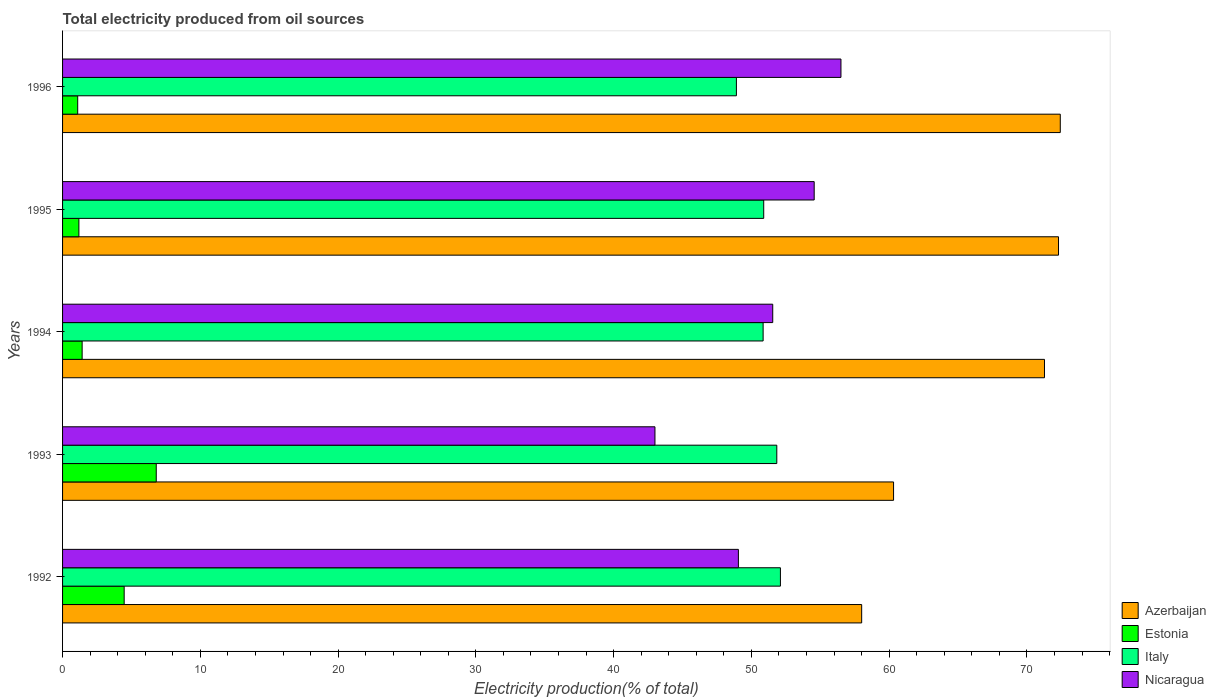How many different coloured bars are there?
Offer a terse response. 4. How many groups of bars are there?
Your answer should be very brief. 5. Are the number of bars per tick equal to the number of legend labels?
Make the answer very short. Yes. Are the number of bars on each tick of the Y-axis equal?
Provide a short and direct response. Yes. What is the label of the 3rd group of bars from the top?
Provide a succinct answer. 1994. In how many cases, is the number of bars for a given year not equal to the number of legend labels?
Offer a terse response. 0. What is the total electricity produced in Italy in 1993?
Keep it short and to the point. 51.84. Across all years, what is the maximum total electricity produced in Nicaragua?
Give a very brief answer. 56.5. Across all years, what is the minimum total electricity produced in Nicaragua?
Provide a succinct answer. 43. In which year was the total electricity produced in Estonia minimum?
Provide a succinct answer. 1996. What is the total total electricity produced in Nicaragua in the graph?
Ensure brevity in your answer.  254.65. What is the difference between the total electricity produced in Azerbaijan in 1993 and that in 1995?
Make the answer very short. -11.97. What is the difference between the total electricity produced in Estonia in 1994 and the total electricity produced in Italy in 1995?
Make the answer very short. -49.47. What is the average total electricity produced in Azerbaijan per year?
Offer a terse response. 66.86. In the year 1993, what is the difference between the total electricity produced in Azerbaijan and total electricity produced in Estonia?
Offer a very short reply. 53.52. What is the ratio of the total electricity produced in Italy in 1992 to that in 1993?
Ensure brevity in your answer.  1.01. Is the total electricity produced in Italy in 1992 less than that in 1993?
Provide a short and direct response. No. Is the difference between the total electricity produced in Azerbaijan in 1993 and 1996 greater than the difference between the total electricity produced in Estonia in 1993 and 1996?
Your answer should be compact. No. What is the difference between the highest and the second highest total electricity produced in Nicaragua?
Your answer should be very brief. 1.94. What is the difference between the highest and the lowest total electricity produced in Estonia?
Your answer should be compact. 5.7. In how many years, is the total electricity produced in Estonia greater than the average total electricity produced in Estonia taken over all years?
Your response must be concise. 2. Is it the case that in every year, the sum of the total electricity produced in Azerbaijan and total electricity produced in Italy is greater than the sum of total electricity produced in Nicaragua and total electricity produced in Estonia?
Your answer should be compact. Yes. What does the 1st bar from the top in 1994 represents?
Offer a very short reply. Nicaragua. What does the 3rd bar from the bottom in 1996 represents?
Provide a short and direct response. Italy. Is it the case that in every year, the sum of the total electricity produced in Azerbaijan and total electricity produced in Italy is greater than the total electricity produced in Estonia?
Ensure brevity in your answer.  Yes. How many bars are there?
Offer a terse response. 20. Are all the bars in the graph horizontal?
Provide a short and direct response. Yes. How many legend labels are there?
Give a very brief answer. 4. How are the legend labels stacked?
Offer a very short reply. Vertical. What is the title of the graph?
Ensure brevity in your answer.  Total electricity produced from oil sources. Does "Barbados" appear as one of the legend labels in the graph?
Your answer should be compact. No. What is the label or title of the X-axis?
Keep it short and to the point. Electricity production(% of total). What is the label or title of the Y-axis?
Your response must be concise. Years. What is the Electricity production(% of total) of Azerbaijan in 1992?
Give a very brief answer. 58. What is the Electricity production(% of total) in Estonia in 1992?
Your answer should be very brief. 4.47. What is the Electricity production(% of total) of Italy in 1992?
Your answer should be compact. 52.1. What is the Electricity production(% of total) in Nicaragua in 1992?
Your answer should be very brief. 49.05. What is the Electricity production(% of total) of Azerbaijan in 1993?
Make the answer very short. 60.32. What is the Electricity production(% of total) in Estonia in 1993?
Keep it short and to the point. 6.8. What is the Electricity production(% of total) of Italy in 1993?
Give a very brief answer. 51.84. What is the Electricity production(% of total) of Nicaragua in 1993?
Offer a very short reply. 43. What is the Electricity production(% of total) of Azerbaijan in 1994?
Offer a terse response. 71.27. What is the Electricity production(% of total) in Estonia in 1994?
Make the answer very short. 1.42. What is the Electricity production(% of total) in Italy in 1994?
Offer a terse response. 50.85. What is the Electricity production(% of total) of Nicaragua in 1994?
Make the answer very short. 51.55. What is the Electricity production(% of total) of Azerbaijan in 1995?
Your answer should be compact. 72.29. What is the Electricity production(% of total) of Estonia in 1995?
Ensure brevity in your answer.  1.18. What is the Electricity production(% of total) in Italy in 1995?
Your answer should be compact. 50.89. What is the Electricity production(% of total) of Nicaragua in 1995?
Make the answer very short. 54.56. What is the Electricity production(% of total) of Azerbaijan in 1996?
Give a very brief answer. 72.42. What is the Electricity production(% of total) in Estonia in 1996?
Make the answer very short. 1.1. What is the Electricity production(% of total) of Italy in 1996?
Make the answer very short. 48.91. What is the Electricity production(% of total) in Nicaragua in 1996?
Provide a short and direct response. 56.5. Across all years, what is the maximum Electricity production(% of total) in Azerbaijan?
Offer a terse response. 72.42. Across all years, what is the maximum Electricity production(% of total) of Estonia?
Give a very brief answer. 6.8. Across all years, what is the maximum Electricity production(% of total) in Italy?
Make the answer very short. 52.1. Across all years, what is the maximum Electricity production(% of total) of Nicaragua?
Ensure brevity in your answer.  56.5. Across all years, what is the minimum Electricity production(% of total) in Azerbaijan?
Offer a terse response. 58. Across all years, what is the minimum Electricity production(% of total) of Estonia?
Your answer should be very brief. 1.1. Across all years, what is the minimum Electricity production(% of total) in Italy?
Offer a terse response. 48.91. Across all years, what is the minimum Electricity production(% of total) of Nicaragua?
Your answer should be compact. 43. What is the total Electricity production(% of total) in Azerbaijan in the graph?
Your answer should be very brief. 334.3. What is the total Electricity production(% of total) in Estonia in the graph?
Ensure brevity in your answer.  14.98. What is the total Electricity production(% of total) in Italy in the graph?
Offer a terse response. 254.6. What is the total Electricity production(% of total) of Nicaragua in the graph?
Provide a short and direct response. 254.65. What is the difference between the Electricity production(% of total) of Azerbaijan in 1992 and that in 1993?
Your answer should be very brief. -2.31. What is the difference between the Electricity production(% of total) of Estonia in 1992 and that in 1993?
Your response must be concise. -2.33. What is the difference between the Electricity production(% of total) of Italy in 1992 and that in 1993?
Your answer should be compact. 0.26. What is the difference between the Electricity production(% of total) in Nicaragua in 1992 and that in 1993?
Your answer should be compact. 6.06. What is the difference between the Electricity production(% of total) of Azerbaijan in 1992 and that in 1994?
Give a very brief answer. -13.27. What is the difference between the Electricity production(% of total) of Estonia in 1992 and that in 1994?
Your answer should be compact. 3.05. What is the difference between the Electricity production(% of total) of Italy in 1992 and that in 1994?
Your answer should be very brief. 1.26. What is the difference between the Electricity production(% of total) of Nicaragua in 1992 and that in 1994?
Your answer should be very brief. -2.49. What is the difference between the Electricity production(% of total) of Azerbaijan in 1992 and that in 1995?
Give a very brief answer. -14.29. What is the difference between the Electricity production(% of total) in Estonia in 1992 and that in 1995?
Ensure brevity in your answer.  3.29. What is the difference between the Electricity production(% of total) in Italy in 1992 and that in 1995?
Make the answer very short. 1.21. What is the difference between the Electricity production(% of total) in Nicaragua in 1992 and that in 1995?
Your answer should be compact. -5.5. What is the difference between the Electricity production(% of total) in Azerbaijan in 1992 and that in 1996?
Offer a very short reply. -14.42. What is the difference between the Electricity production(% of total) in Estonia in 1992 and that in 1996?
Ensure brevity in your answer.  3.37. What is the difference between the Electricity production(% of total) of Italy in 1992 and that in 1996?
Your answer should be very brief. 3.2. What is the difference between the Electricity production(% of total) in Nicaragua in 1992 and that in 1996?
Your answer should be compact. -7.44. What is the difference between the Electricity production(% of total) of Azerbaijan in 1993 and that in 1994?
Your answer should be compact. -10.95. What is the difference between the Electricity production(% of total) of Estonia in 1993 and that in 1994?
Offer a very short reply. 5.38. What is the difference between the Electricity production(% of total) of Nicaragua in 1993 and that in 1994?
Keep it short and to the point. -8.55. What is the difference between the Electricity production(% of total) in Azerbaijan in 1993 and that in 1995?
Your response must be concise. -11.97. What is the difference between the Electricity production(% of total) in Estonia in 1993 and that in 1995?
Offer a very short reply. 5.62. What is the difference between the Electricity production(% of total) in Italy in 1993 and that in 1995?
Offer a terse response. 0.95. What is the difference between the Electricity production(% of total) in Nicaragua in 1993 and that in 1995?
Your answer should be compact. -11.56. What is the difference between the Electricity production(% of total) of Azerbaijan in 1993 and that in 1996?
Offer a very short reply. -12.1. What is the difference between the Electricity production(% of total) of Estonia in 1993 and that in 1996?
Make the answer very short. 5.7. What is the difference between the Electricity production(% of total) of Italy in 1993 and that in 1996?
Provide a short and direct response. 2.93. What is the difference between the Electricity production(% of total) of Nicaragua in 1993 and that in 1996?
Offer a terse response. -13.5. What is the difference between the Electricity production(% of total) of Azerbaijan in 1994 and that in 1995?
Your response must be concise. -1.02. What is the difference between the Electricity production(% of total) of Estonia in 1994 and that in 1995?
Offer a very short reply. 0.24. What is the difference between the Electricity production(% of total) in Italy in 1994 and that in 1995?
Offer a very short reply. -0.04. What is the difference between the Electricity production(% of total) of Nicaragua in 1994 and that in 1995?
Keep it short and to the point. -3.01. What is the difference between the Electricity production(% of total) of Azerbaijan in 1994 and that in 1996?
Your answer should be very brief. -1.15. What is the difference between the Electricity production(% of total) in Estonia in 1994 and that in 1996?
Your answer should be very brief. 0.32. What is the difference between the Electricity production(% of total) of Italy in 1994 and that in 1996?
Your answer should be compact. 1.94. What is the difference between the Electricity production(% of total) of Nicaragua in 1994 and that in 1996?
Make the answer very short. -4.95. What is the difference between the Electricity production(% of total) in Azerbaijan in 1995 and that in 1996?
Provide a short and direct response. -0.13. What is the difference between the Electricity production(% of total) in Estonia in 1995 and that in 1996?
Keep it short and to the point. 0.09. What is the difference between the Electricity production(% of total) in Italy in 1995 and that in 1996?
Offer a terse response. 1.98. What is the difference between the Electricity production(% of total) in Nicaragua in 1995 and that in 1996?
Your answer should be very brief. -1.94. What is the difference between the Electricity production(% of total) of Azerbaijan in 1992 and the Electricity production(% of total) of Estonia in 1993?
Keep it short and to the point. 51.2. What is the difference between the Electricity production(% of total) in Azerbaijan in 1992 and the Electricity production(% of total) in Italy in 1993?
Offer a very short reply. 6.16. What is the difference between the Electricity production(% of total) in Azerbaijan in 1992 and the Electricity production(% of total) in Nicaragua in 1993?
Your answer should be compact. 15.01. What is the difference between the Electricity production(% of total) of Estonia in 1992 and the Electricity production(% of total) of Italy in 1993?
Your answer should be very brief. -47.37. What is the difference between the Electricity production(% of total) in Estonia in 1992 and the Electricity production(% of total) in Nicaragua in 1993?
Provide a succinct answer. -38.53. What is the difference between the Electricity production(% of total) in Italy in 1992 and the Electricity production(% of total) in Nicaragua in 1993?
Provide a succinct answer. 9.11. What is the difference between the Electricity production(% of total) in Azerbaijan in 1992 and the Electricity production(% of total) in Estonia in 1994?
Make the answer very short. 56.58. What is the difference between the Electricity production(% of total) of Azerbaijan in 1992 and the Electricity production(% of total) of Italy in 1994?
Offer a very short reply. 7.15. What is the difference between the Electricity production(% of total) of Azerbaijan in 1992 and the Electricity production(% of total) of Nicaragua in 1994?
Keep it short and to the point. 6.46. What is the difference between the Electricity production(% of total) in Estonia in 1992 and the Electricity production(% of total) in Italy in 1994?
Your answer should be very brief. -46.38. What is the difference between the Electricity production(% of total) in Estonia in 1992 and the Electricity production(% of total) in Nicaragua in 1994?
Provide a succinct answer. -47.08. What is the difference between the Electricity production(% of total) of Italy in 1992 and the Electricity production(% of total) of Nicaragua in 1994?
Provide a succinct answer. 0.56. What is the difference between the Electricity production(% of total) of Azerbaijan in 1992 and the Electricity production(% of total) of Estonia in 1995?
Provide a succinct answer. 56.82. What is the difference between the Electricity production(% of total) in Azerbaijan in 1992 and the Electricity production(% of total) in Italy in 1995?
Keep it short and to the point. 7.11. What is the difference between the Electricity production(% of total) in Azerbaijan in 1992 and the Electricity production(% of total) in Nicaragua in 1995?
Ensure brevity in your answer.  3.45. What is the difference between the Electricity production(% of total) of Estonia in 1992 and the Electricity production(% of total) of Italy in 1995?
Keep it short and to the point. -46.42. What is the difference between the Electricity production(% of total) of Estonia in 1992 and the Electricity production(% of total) of Nicaragua in 1995?
Offer a terse response. -50.08. What is the difference between the Electricity production(% of total) in Italy in 1992 and the Electricity production(% of total) in Nicaragua in 1995?
Your answer should be very brief. -2.45. What is the difference between the Electricity production(% of total) of Azerbaijan in 1992 and the Electricity production(% of total) of Estonia in 1996?
Make the answer very short. 56.9. What is the difference between the Electricity production(% of total) in Azerbaijan in 1992 and the Electricity production(% of total) in Italy in 1996?
Provide a short and direct response. 9.09. What is the difference between the Electricity production(% of total) in Azerbaijan in 1992 and the Electricity production(% of total) in Nicaragua in 1996?
Provide a short and direct response. 1.5. What is the difference between the Electricity production(% of total) in Estonia in 1992 and the Electricity production(% of total) in Italy in 1996?
Give a very brief answer. -44.44. What is the difference between the Electricity production(% of total) of Estonia in 1992 and the Electricity production(% of total) of Nicaragua in 1996?
Provide a succinct answer. -52.03. What is the difference between the Electricity production(% of total) in Italy in 1992 and the Electricity production(% of total) in Nicaragua in 1996?
Your answer should be very brief. -4.39. What is the difference between the Electricity production(% of total) of Azerbaijan in 1993 and the Electricity production(% of total) of Estonia in 1994?
Your answer should be very brief. 58.9. What is the difference between the Electricity production(% of total) of Azerbaijan in 1993 and the Electricity production(% of total) of Italy in 1994?
Give a very brief answer. 9.47. What is the difference between the Electricity production(% of total) of Azerbaijan in 1993 and the Electricity production(% of total) of Nicaragua in 1994?
Keep it short and to the point. 8.77. What is the difference between the Electricity production(% of total) of Estonia in 1993 and the Electricity production(% of total) of Italy in 1994?
Provide a short and direct response. -44.05. What is the difference between the Electricity production(% of total) in Estonia in 1993 and the Electricity production(% of total) in Nicaragua in 1994?
Provide a short and direct response. -44.75. What is the difference between the Electricity production(% of total) of Italy in 1993 and the Electricity production(% of total) of Nicaragua in 1994?
Your answer should be very brief. 0.3. What is the difference between the Electricity production(% of total) in Azerbaijan in 1993 and the Electricity production(% of total) in Estonia in 1995?
Offer a terse response. 59.13. What is the difference between the Electricity production(% of total) in Azerbaijan in 1993 and the Electricity production(% of total) in Italy in 1995?
Provide a short and direct response. 9.42. What is the difference between the Electricity production(% of total) of Azerbaijan in 1993 and the Electricity production(% of total) of Nicaragua in 1995?
Your answer should be compact. 5.76. What is the difference between the Electricity production(% of total) of Estonia in 1993 and the Electricity production(% of total) of Italy in 1995?
Offer a terse response. -44.09. What is the difference between the Electricity production(% of total) in Estonia in 1993 and the Electricity production(% of total) in Nicaragua in 1995?
Offer a terse response. -47.75. What is the difference between the Electricity production(% of total) in Italy in 1993 and the Electricity production(% of total) in Nicaragua in 1995?
Your response must be concise. -2.71. What is the difference between the Electricity production(% of total) in Azerbaijan in 1993 and the Electricity production(% of total) in Estonia in 1996?
Your response must be concise. 59.22. What is the difference between the Electricity production(% of total) in Azerbaijan in 1993 and the Electricity production(% of total) in Italy in 1996?
Your response must be concise. 11.41. What is the difference between the Electricity production(% of total) in Azerbaijan in 1993 and the Electricity production(% of total) in Nicaragua in 1996?
Provide a succinct answer. 3.82. What is the difference between the Electricity production(% of total) of Estonia in 1993 and the Electricity production(% of total) of Italy in 1996?
Your answer should be very brief. -42.11. What is the difference between the Electricity production(% of total) of Estonia in 1993 and the Electricity production(% of total) of Nicaragua in 1996?
Offer a very short reply. -49.7. What is the difference between the Electricity production(% of total) of Italy in 1993 and the Electricity production(% of total) of Nicaragua in 1996?
Your answer should be compact. -4.66. What is the difference between the Electricity production(% of total) in Azerbaijan in 1994 and the Electricity production(% of total) in Estonia in 1995?
Your response must be concise. 70.09. What is the difference between the Electricity production(% of total) of Azerbaijan in 1994 and the Electricity production(% of total) of Italy in 1995?
Provide a short and direct response. 20.38. What is the difference between the Electricity production(% of total) in Azerbaijan in 1994 and the Electricity production(% of total) in Nicaragua in 1995?
Your answer should be very brief. 16.72. What is the difference between the Electricity production(% of total) in Estonia in 1994 and the Electricity production(% of total) in Italy in 1995?
Make the answer very short. -49.47. What is the difference between the Electricity production(% of total) in Estonia in 1994 and the Electricity production(% of total) in Nicaragua in 1995?
Ensure brevity in your answer.  -53.13. What is the difference between the Electricity production(% of total) in Italy in 1994 and the Electricity production(% of total) in Nicaragua in 1995?
Offer a terse response. -3.71. What is the difference between the Electricity production(% of total) of Azerbaijan in 1994 and the Electricity production(% of total) of Estonia in 1996?
Your answer should be very brief. 70.17. What is the difference between the Electricity production(% of total) of Azerbaijan in 1994 and the Electricity production(% of total) of Italy in 1996?
Offer a very short reply. 22.36. What is the difference between the Electricity production(% of total) in Azerbaijan in 1994 and the Electricity production(% of total) in Nicaragua in 1996?
Provide a short and direct response. 14.77. What is the difference between the Electricity production(% of total) in Estonia in 1994 and the Electricity production(% of total) in Italy in 1996?
Your answer should be compact. -47.49. What is the difference between the Electricity production(% of total) of Estonia in 1994 and the Electricity production(% of total) of Nicaragua in 1996?
Give a very brief answer. -55.08. What is the difference between the Electricity production(% of total) of Italy in 1994 and the Electricity production(% of total) of Nicaragua in 1996?
Provide a short and direct response. -5.65. What is the difference between the Electricity production(% of total) of Azerbaijan in 1995 and the Electricity production(% of total) of Estonia in 1996?
Provide a succinct answer. 71.19. What is the difference between the Electricity production(% of total) of Azerbaijan in 1995 and the Electricity production(% of total) of Italy in 1996?
Offer a very short reply. 23.38. What is the difference between the Electricity production(% of total) of Azerbaijan in 1995 and the Electricity production(% of total) of Nicaragua in 1996?
Make the answer very short. 15.79. What is the difference between the Electricity production(% of total) in Estonia in 1995 and the Electricity production(% of total) in Italy in 1996?
Make the answer very short. -47.72. What is the difference between the Electricity production(% of total) in Estonia in 1995 and the Electricity production(% of total) in Nicaragua in 1996?
Give a very brief answer. -55.31. What is the difference between the Electricity production(% of total) in Italy in 1995 and the Electricity production(% of total) in Nicaragua in 1996?
Your answer should be compact. -5.61. What is the average Electricity production(% of total) in Azerbaijan per year?
Keep it short and to the point. 66.86. What is the average Electricity production(% of total) of Estonia per year?
Make the answer very short. 3. What is the average Electricity production(% of total) in Italy per year?
Offer a very short reply. 50.92. What is the average Electricity production(% of total) of Nicaragua per year?
Provide a succinct answer. 50.93. In the year 1992, what is the difference between the Electricity production(% of total) in Azerbaijan and Electricity production(% of total) in Estonia?
Provide a succinct answer. 53.53. In the year 1992, what is the difference between the Electricity production(% of total) of Azerbaijan and Electricity production(% of total) of Italy?
Your answer should be very brief. 5.9. In the year 1992, what is the difference between the Electricity production(% of total) of Azerbaijan and Electricity production(% of total) of Nicaragua?
Keep it short and to the point. 8.95. In the year 1992, what is the difference between the Electricity production(% of total) in Estonia and Electricity production(% of total) in Italy?
Offer a very short reply. -47.63. In the year 1992, what is the difference between the Electricity production(% of total) in Estonia and Electricity production(% of total) in Nicaragua?
Give a very brief answer. -44.58. In the year 1992, what is the difference between the Electricity production(% of total) of Italy and Electricity production(% of total) of Nicaragua?
Offer a very short reply. 3.05. In the year 1993, what is the difference between the Electricity production(% of total) in Azerbaijan and Electricity production(% of total) in Estonia?
Provide a short and direct response. 53.52. In the year 1993, what is the difference between the Electricity production(% of total) of Azerbaijan and Electricity production(% of total) of Italy?
Provide a short and direct response. 8.48. In the year 1993, what is the difference between the Electricity production(% of total) in Azerbaijan and Electricity production(% of total) in Nicaragua?
Your response must be concise. 17.32. In the year 1993, what is the difference between the Electricity production(% of total) of Estonia and Electricity production(% of total) of Italy?
Your answer should be very brief. -45.04. In the year 1993, what is the difference between the Electricity production(% of total) in Estonia and Electricity production(% of total) in Nicaragua?
Provide a succinct answer. -36.2. In the year 1993, what is the difference between the Electricity production(% of total) of Italy and Electricity production(% of total) of Nicaragua?
Keep it short and to the point. 8.84. In the year 1994, what is the difference between the Electricity production(% of total) of Azerbaijan and Electricity production(% of total) of Estonia?
Ensure brevity in your answer.  69.85. In the year 1994, what is the difference between the Electricity production(% of total) in Azerbaijan and Electricity production(% of total) in Italy?
Your answer should be very brief. 20.42. In the year 1994, what is the difference between the Electricity production(% of total) of Azerbaijan and Electricity production(% of total) of Nicaragua?
Provide a short and direct response. 19.72. In the year 1994, what is the difference between the Electricity production(% of total) of Estonia and Electricity production(% of total) of Italy?
Your answer should be compact. -49.43. In the year 1994, what is the difference between the Electricity production(% of total) of Estonia and Electricity production(% of total) of Nicaragua?
Give a very brief answer. -50.13. In the year 1994, what is the difference between the Electricity production(% of total) of Italy and Electricity production(% of total) of Nicaragua?
Offer a very short reply. -0.7. In the year 1995, what is the difference between the Electricity production(% of total) in Azerbaijan and Electricity production(% of total) in Estonia?
Offer a terse response. 71.1. In the year 1995, what is the difference between the Electricity production(% of total) of Azerbaijan and Electricity production(% of total) of Italy?
Offer a very short reply. 21.4. In the year 1995, what is the difference between the Electricity production(% of total) of Azerbaijan and Electricity production(% of total) of Nicaragua?
Provide a succinct answer. 17.73. In the year 1995, what is the difference between the Electricity production(% of total) in Estonia and Electricity production(% of total) in Italy?
Give a very brief answer. -49.71. In the year 1995, what is the difference between the Electricity production(% of total) of Estonia and Electricity production(% of total) of Nicaragua?
Offer a terse response. -53.37. In the year 1995, what is the difference between the Electricity production(% of total) in Italy and Electricity production(% of total) in Nicaragua?
Your answer should be compact. -3.66. In the year 1996, what is the difference between the Electricity production(% of total) of Azerbaijan and Electricity production(% of total) of Estonia?
Provide a succinct answer. 71.32. In the year 1996, what is the difference between the Electricity production(% of total) of Azerbaijan and Electricity production(% of total) of Italy?
Offer a very short reply. 23.51. In the year 1996, what is the difference between the Electricity production(% of total) of Azerbaijan and Electricity production(% of total) of Nicaragua?
Provide a succinct answer. 15.92. In the year 1996, what is the difference between the Electricity production(% of total) of Estonia and Electricity production(% of total) of Italy?
Your answer should be compact. -47.81. In the year 1996, what is the difference between the Electricity production(% of total) of Estonia and Electricity production(% of total) of Nicaragua?
Ensure brevity in your answer.  -55.4. In the year 1996, what is the difference between the Electricity production(% of total) of Italy and Electricity production(% of total) of Nicaragua?
Your answer should be compact. -7.59. What is the ratio of the Electricity production(% of total) in Azerbaijan in 1992 to that in 1993?
Provide a short and direct response. 0.96. What is the ratio of the Electricity production(% of total) in Estonia in 1992 to that in 1993?
Give a very brief answer. 0.66. What is the ratio of the Electricity production(% of total) of Nicaragua in 1992 to that in 1993?
Provide a short and direct response. 1.14. What is the ratio of the Electricity production(% of total) of Azerbaijan in 1992 to that in 1994?
Offer a terse response. 0.81. What is the ratio of the Electricity production(% of total) in Estonia in 1992 to that in 1994?
Provide a succinct answer. 3.15. What is the ratio of the Electricity production(% of total) in Italy in 1992 to that in 1994?
Provide a succinct answer. 1.02. What is the ratio of the Electricity production(% of total) in Nicaragua in 1992 to that in 1994?
Your answer should be very brief. 0.95. What is the ratio of the Electricity production(% of total) of Azerbaijan in 1992 to that in 1995?
Offer a terse response. 0.8. What is the ratio of the Electricity production(% of total) in Estonia in 1992 to that in 1995?
Ensure brevity in your answer.  3.77. What is the ratio of the Electricity production(% of total) in Italy in 1992 to that in 1995?
Your answer should be very brief. 1.02. What is the ratio of the Electricity production(% of total) in Nicaragua in 1992 to that in 1995?
Your answer should be compact. 0.9. What is the ratio of the Electricity production(% of total) of Azerbaijan in 1992 to that in 1996?
Provide a short and direct response. 0.8. What is the ratio of the Electricity production(% of total) in Estonia in 1992 to that in 1996?
Your answer should be very brief. 4.07. What is the ratio of the Electricity production(% of total) of Italy in 1992 to that in 1996?
Your answer should be very brief. 1.07. What is the ratio of the Electricity production(% of total) in Nicaragua in 1992 to that in 1996?
Provide a short and direct response. 0.87. What is the ratio of the Electricity production(% of total) of Azerbaijan in 1993 to that in 1994?
Your response must be concise. 0.85. What is the ratio of the Electricity production(% of total) of Estonia in 1993 to that in 1994?
Your answer should be very brief. 4.79. What is the ratio of the Electricity production(% of total) in Italy in 1993 to that in 1994?
Provide a short and direct response. 1.02. What is the ratio of the Electricity production(% of total) of Nicaragua in 1993 to that in 1994?
Your answer should be compact. 0.83. What is the ratio of the Electricity production(% of total) of Azerbaijan in 1993 to that in 1995?
Ensure brevity in your answer.  0.83. What is the ratio of the Electricity production(% of total) of Estonia in 1993 to that in 1995?
Provide a succinct answer. 5.74. What is the ratio of the Electricity production(% of total) in Italy in 1993 to that in 1995?
Your answer should be very brief. 1.02. What is the ratio of the Electricity production(% of total) of Nicaragua in 1993 to that in 1995?
Your answer should be very brief. 0.79. What is the ratio of the Electricity production(% of total) in Azerbaijan in 1993 to that in 1996?
Provide a short and direct response. 0.83. What is the ratio of the Electricity production(% of total) in Estonia in 1993 to that in 1996?
Give a very brief answer. 6.19. What is the ratio of the Electricity production(% of total) in Italy in 1993 to that in 1996?
Provide a succinct answer. 1.06. What is the ratio of the Electricity production(% of total) in Nicaragua in 1993 to that in 1996?
Ensure brevity in your answer.  0.76. What is the ratio of the Electricity production(% of total) in Azerbaijan in 1994 to that in 1995?
Provide a short and direct response. 0.99. What is the ratio of the Electricity production(% of total) of Estonia in 1994 to that in 1995?
Provide a short and direct response. 1.2. What is the ratio of the Electricity production(% of total) of Nicaragua in 1994 to that in 1995?
Your answer should be very brief. 0.94. What is the ratio of the Electricity production(% of total) of Azerbaijan in 1994 to that in 1996?
Give a very brief answer. 0.98. What is the ratio of the Electricity production(% of total) in Estonia in 1994 to that in 1996?
Make the answer very short. 1.29. What is the ratio of the Electricity production(% of total) of Italy in 1994 to that in 1996?
Provide a short and direct response. 1.04. What is the ratio of the Electricity production(% of total) of Nicaragua in 1994 to that in 1996?
Your response must be concise. 0.91. What is the ratio of the Electricity production(% of total) in Azerbaijan in 1995 to that in 1996?
Provide a succinct answer. 1. What is the ratio of the Electricity production(% of total) of Estonia in 1995 to that in 1996?
Keep it short and to the point. 1.08. What is the ratio of the Electricity production(% of total) in Italy in 1995 to that in 1996?
Your answer should be very brief. 1.04. What is the ratio of the Electricity production(% of total) in Nicaragua in 1995 to that in 1996?
Provide a succinct answer. 0.97. What is the difference between the highest and the second highest Electricity production(% of total) of Azerbaijan?
Your answer should be very brief. 0.13. What is the difference between the highest and the second highest Electricity production(% of total) in Estonia?
Give a very brief answer. 2.33. What is the difference between the highest and the second highest Electricity production(% of total) in Italy?
Offer a very short reply. 0.26. What is the difference between the highest and the second highest Electricity production(% of total) in Nicaragua?
Ensure brevity in your answer.  1.94. What is the difference between the highest and the lowest Electricity production(% of total) of Azerbaijan?
Your answer should be very brief. 14.42. What is the difference between the highest and the lowest Electricity production(% of total) of Estonia?
Your answer should be very brief. 5.7. What is the difference between the highest and the lowest Electricity production(% of total) in Italy?
Your answer should be very brief. 3.2. What is the difference between the highest and the lowest Electricity production(% of total) in Nicaragua?
Make the answer very short. 13.5. 